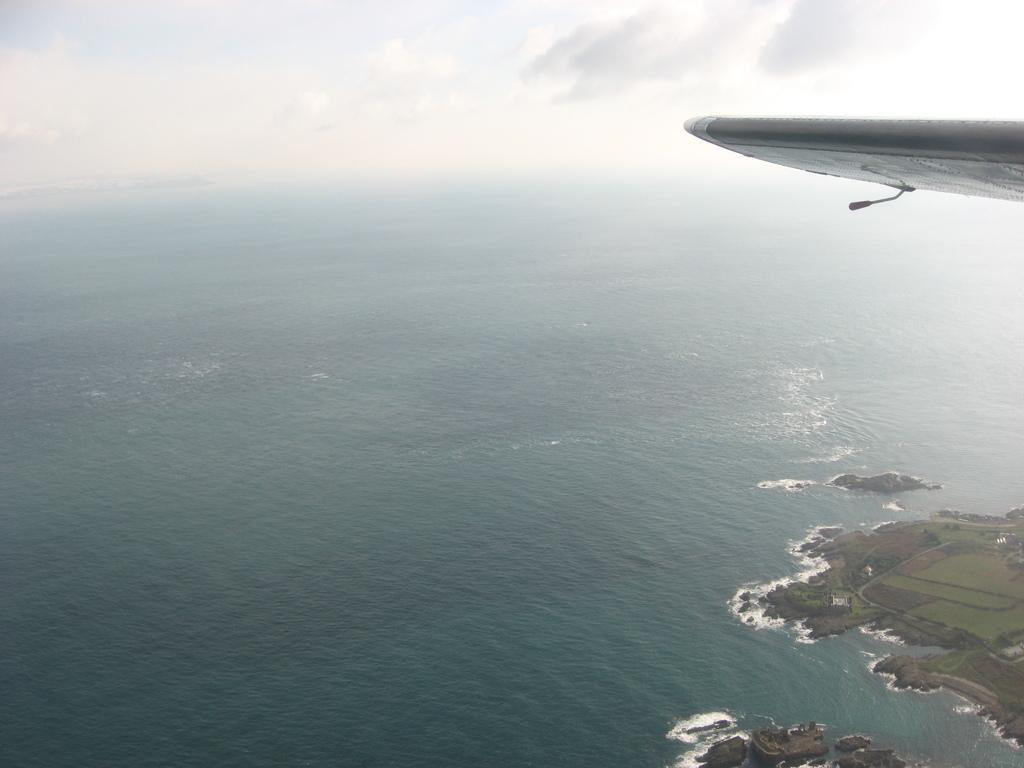What can be seen on the right side of the image? There is an aeroplane wing on the right side of the image. What is visible in the background of the image? Water, the sky, clouds, and the ground are visible in the background of the image. Can you describe the sky in the image? The sky is visible in the background of the image, and it contains clouds. What type of noise can be heard coming from the dinosaurs in the image? There are no dinosaurs present in the image, so it's not possible to determine what, let alone hear any noise they might make. 